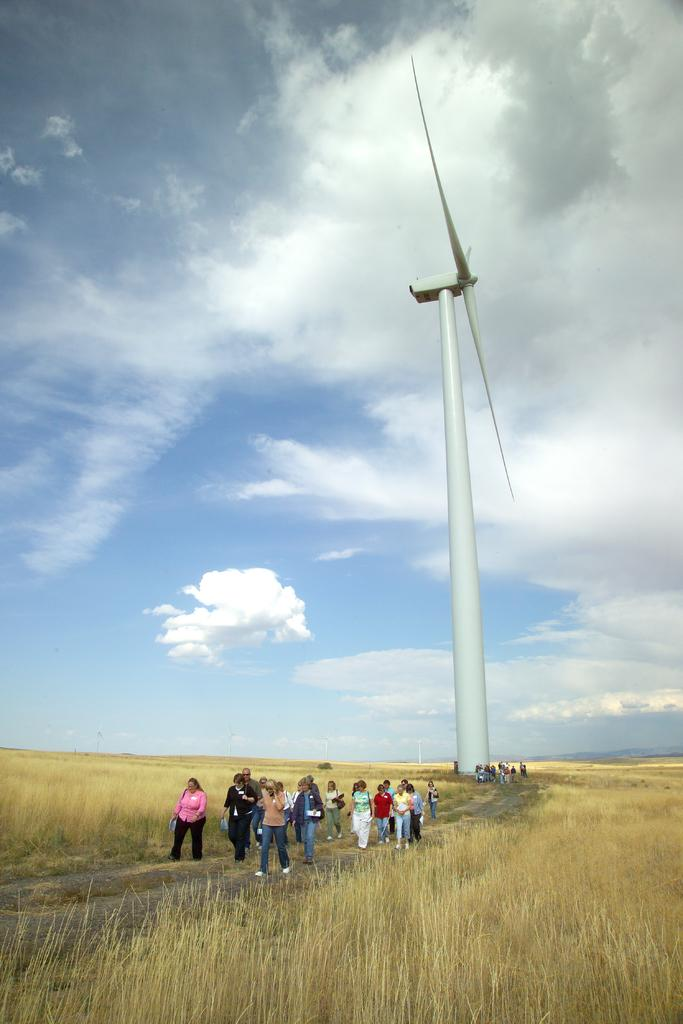What type of structure is in the image? There is a white windmill in the image. Who or what else is present in the image? There is a group of people in the image. What else can be seen in the image besides the windmill and people? There are plants in the image. What is the condition of the sky in the background of the image? The sky is cloudy in the background of the image. What type of spring can be seen in the image? There is no spring present in the image; it features a white windmill, a group of people, plants, and a cloudy sky. How does the land appear in the image? The image does not specifically show the land, but it can be inferred that the windmill, people, and plants are situated on some type of land. 